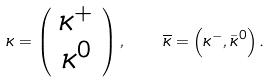Convert formula to latex. <formula><loc_0><loc_0><loc_500><loc_500>\kappa = \left ( \begin{array} { c } \kappa ^ { + } \\ \kappa ^ { 0 } \end{array} \right ) , \quad \overline { \kappa } = \left ( \kappa ^ { - } , \bar { \kappa } ^ { 0 } \right ) .</formula> 